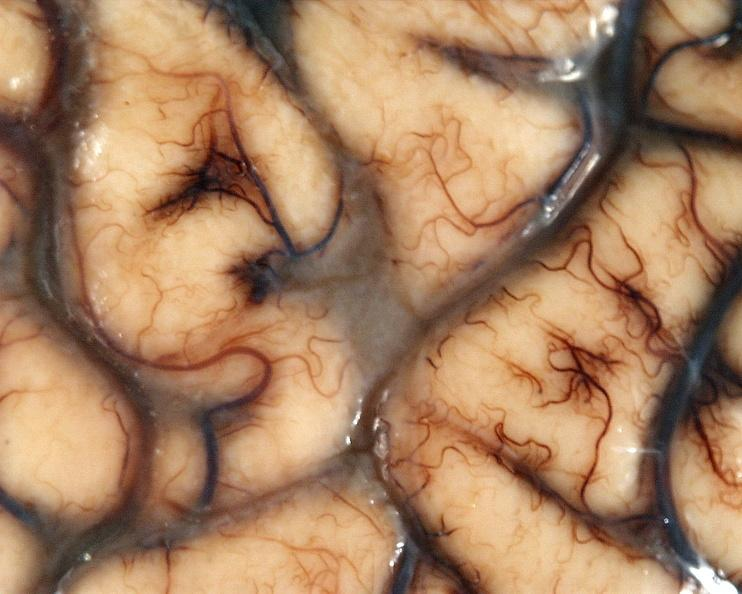does this image show brain, cryptococcal meningitis?
Answer the question using a single word or phrase. Yes 